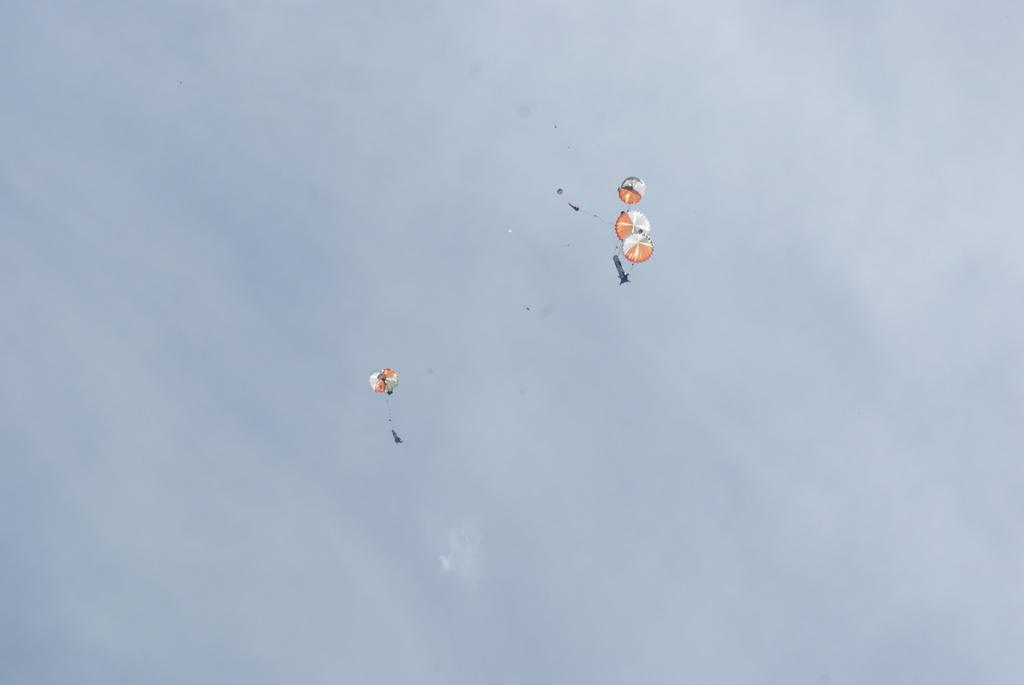How many parachutes can be seen in the image? There are four parachutes in the image. What are the parachutes doing in the image? The parachutes are flying in the sky. What type of credit can be seen on the parachutes in the image? There is no credit visible on the parachutes in the image. How does the throat of the person on the parachute look like in the image? There are no people visible on the parachutes in the image, so it is not possible to determine the appearance of their throats. 